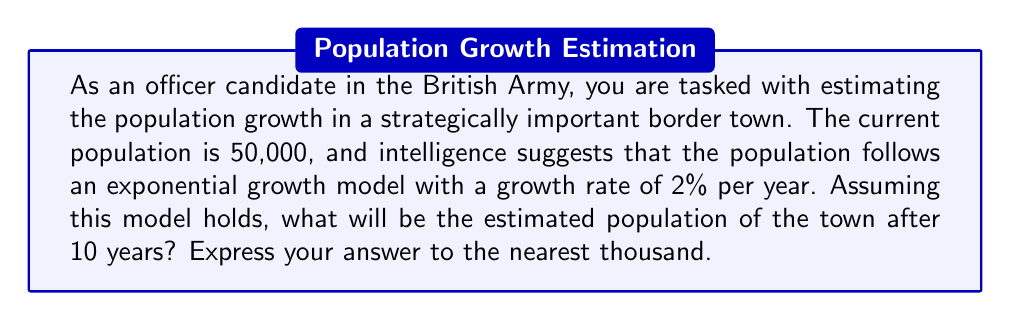What is the answer to this math problem? To solve this problem, we'll use the exponential growth model:

$$P(t) = P_0 e^{rt}$$

Where:
$P(t)$ is the population at time $t$
$P_0$ is the initial population
$r$ is the growth rate (as a decimal)
$t$ is the time in years
$e$ is Euler's number (approximately 2.71828)

Given:
$P_0 = 50,000$ (initial population)
$r = 0.02$ (2% growth rate expressed as a decimal)
$t = 10$ years

Let's substitute these values into the equation:

$$P(10) = 50,000 \cdot e^{0.02 \cdot 10}$$

Now we can calculate:

$$P(10) = 50,000 \cdot e^{0.2}$$
$$P(10) = 50,000 \cdot 1.2214$$
$$P(10) = 61,070$$

Rounding to the nearest thousand:

$$P(10) \approx 61,000$$

This result indicates that the population is expected to grow from 50,000 to approximately 61,000 over the 10-year period.
Answer: 61,000 